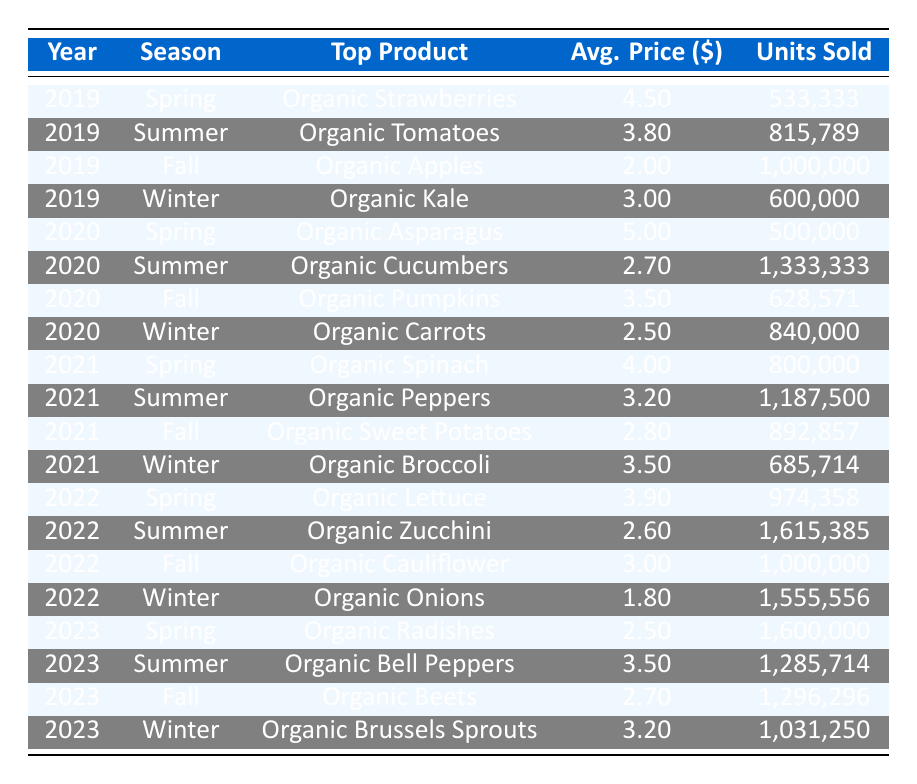What was the top-selling organic produce item in Summer 2021? In the table, the row for Summer 2021 shows that the top product was "Organic Peppers."
Answer: Organic Peppers Which season had the highest organic produce sales in 2023? In the table, comparing the organic produce sales for each season in 2023, Spring had 4,000,000, Summer 4,500,000, Fall 3,500,000, and Winter 3,300,000. Summer had the highest sales at 4,500,000.
Answer: Summer How many units of organic tomatoes were sold in Summer 2019? The row for Summer 2019 shows that 815,789 units of organic tomatoes were sold.
Answer: 815,789 What was the average price of organic produce in Fall 2022, and how does it compare to Fall 2021? The average price in Fall 2022 for organic cauliflower was 3.00, while in Fall 2021 for organic sweet potatoes, it was 2.80. Comparing them, 3.00 is greater than 2.80, indicating an increase in average price in 2022 compared to 2021.
Answer: 3.00, greater than 2.80 Did organic produce sales generally increase from Winter 2019 to Winter 2023? The organic produce sales in Winter for each year from 2019 to 2023 are as follows: 1,800,000 (2019), 2,100,000 (2020), 2,400,000 (2021), 2,800,000 (2022), and 3,300,000 (2023). This shows a consistent increase in sales across these years, indicating a general increase in organic produce sales during Winter.
Answer: Yes What is the total sales volume of organic produce in Spring across all five years? To calculate the total sales volume in Spring, we add the sales for each Spring from 2019 to 2023: 2,400,000 (2019) + 2,500,000 (2020) + 3,200,000 (2021) + 3,800,000 (2022) + 4,000,000 (2023) = 16,900,000.
Answer: 16,900,000 What is the average unit sold across all seasons in 2022? The total units sold in 2022 are: 974,358 (Spring) + 1,615,385 (Summer) + 1,000,000 (Fall) + 1,555,556 (Winter) = 5,145,299 units. To find the average, we divide this by 4 (the number of seasons), which equals about 1,286,324.75.
Answer: 1,286,324.75 Which year experienced the highest sales in Fall and what was the amount? In the table, Fall sales were: 2,000,000 (2019), 2,200,000 (2020), 2,500,000 (2021), 3,000,000 (2022), and 3,500,000 (2023). The highest sales occurred in 2023 with 3,500,000.
Answer: 3,500,000 Was there a decrease in average price per unit for organic produce in the Winter from 2019 to 2020? The average price in Winter 2019 was 3.00, while in Winter 2020 it was 2.50. Since 2.50 is less than 3.00, there was indeed a decrease in the average price per unit.
Answer: Yes 